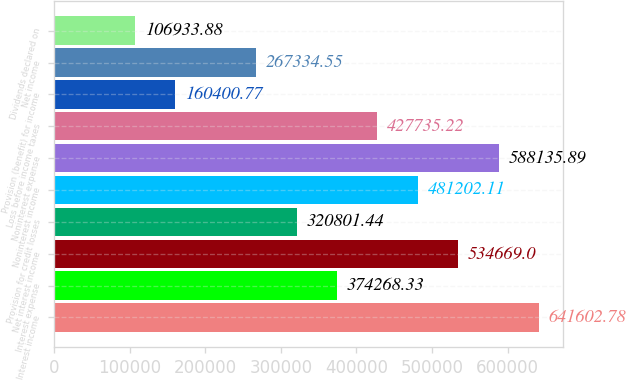<chart> <loc_0><loc_0><loc_500><loc_500><bar_chart><fcel>Interest income<fcel>Interest expense<fcel>Net interest income<fcel>Provision for credit losses<fcel>Noninterest income<fcel>Noninterest expense<fcel>Loss before income taxes<fcel>Provision (benefit) for income<fcel>Net income<fcel>Dividends declared on<nl><fcel>641603<fcel>374268<fcel>534669<fcel>320801<fcel>481202<fcel>588136<fcel>427735<fcel>160401<fcel>267335<fcel>106934<nl></chart> 